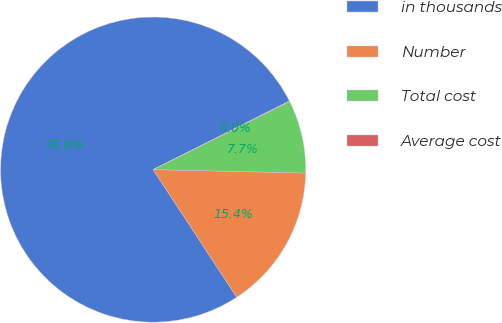Convert chart. <chart><loc_0><loc_0><loc_500><loc_500><pie_chart><fcel>in thousands<fcel>Number<fcel>Total cost<fcel>Average cost<nl><fcel>76.81%<fcel>15.41%<fcel>7.73%<fcel>0.05%<nl></chart> 